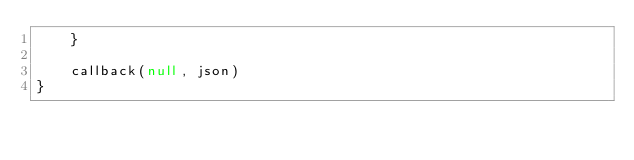<code> <loc_0><loc_0><loc_500><loc_500><_JavaScript_>    }

    callback(null, json)
}
</code> 